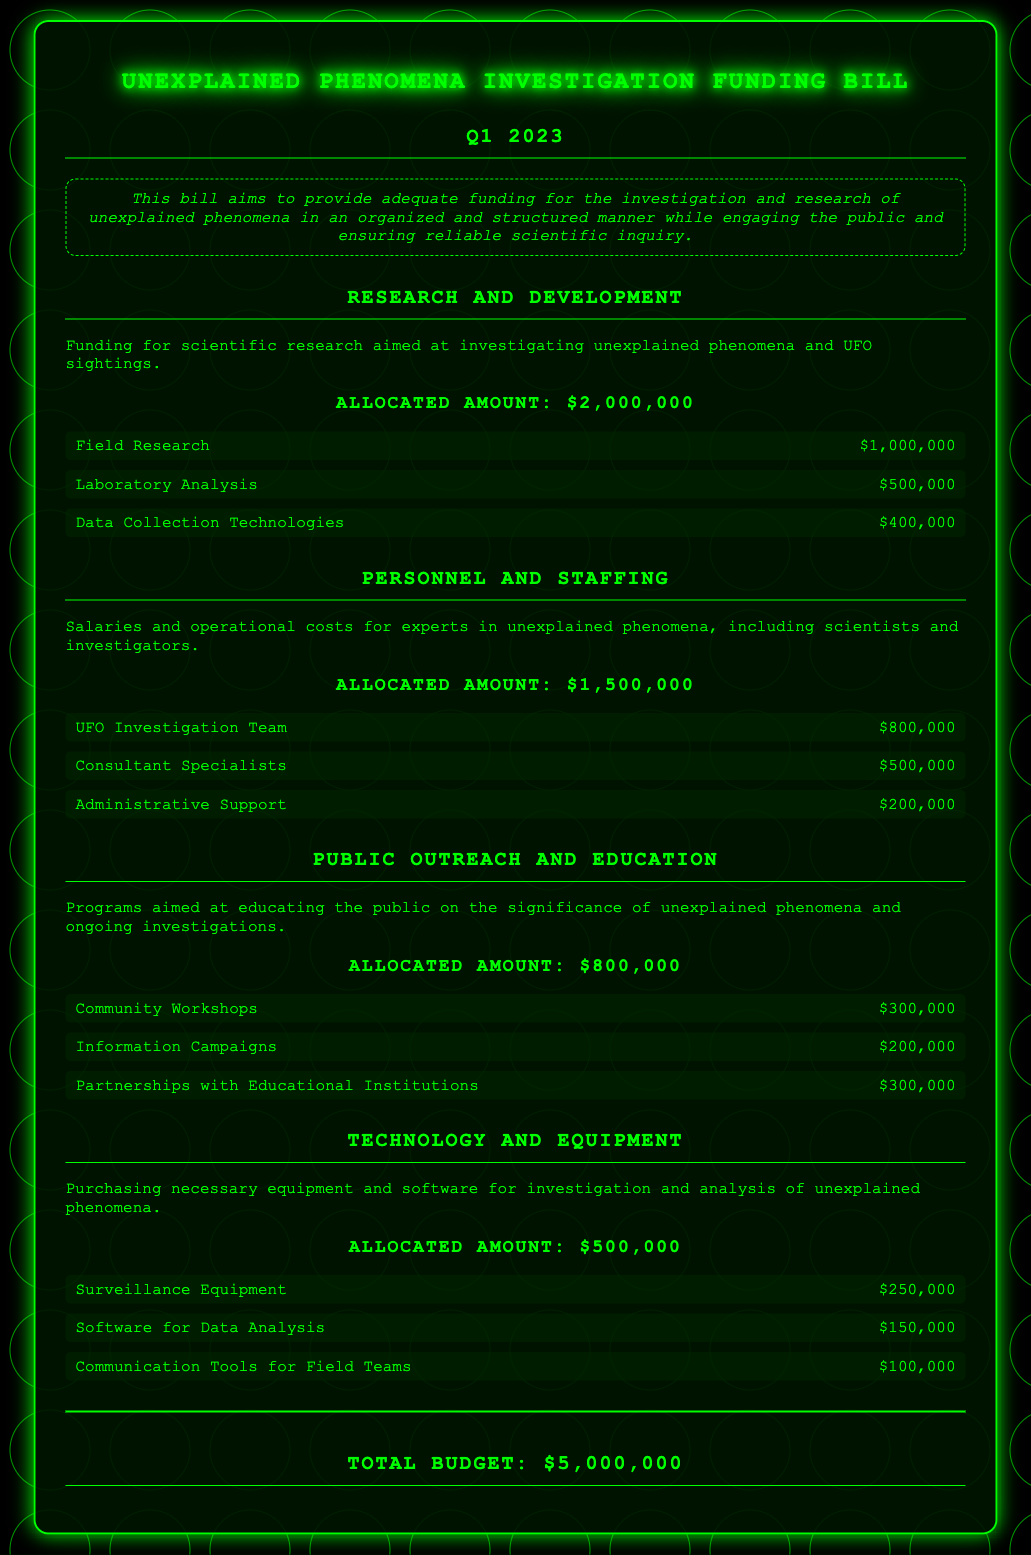what is the total allocated budget? The total allocated budget is the sum of all allocated amounts for each category in the document, which equals $2,000,000 + $1,500,000 + $800,000 + $500,000 = $5,000,000.
Answer: $5,000,000 how much is allocated for Personnel and Staffing? The allocated amount for Personnel and Staffing is explicitly stated in the document.
Answer: $1,500,000 what is the allocated amount for Community Workshops? The amount allocated for Community Workshops is detailed under Public Outreach and Education section.
Answer: $300,000 who receives the highest allocation under Technology and Equipment? The highest allocation under Technology and Equipment refers to the subcategory with the largest amount, which is Surveillance Equipment.
Answer: Surveillance Equipment what is the primary purpose of the bill? The primary aim of the bill is mentioned in the summary at the beginning of the document.
Answer: Funding for the investigation and research of unexplained phenomena how many subcategories are listed under Research and Development? The number of subcategories listed under Research and Development is determined by counting the individual entries provided in that category.
Answer: 3 which category has the least allocated amount? The category with the least allocated amount is identified from the list of allocations provided in the document.
Answer: Technology and Equipment how much is allocated for Information Campaigns? The amount for Information Campaigns is specified under Public Outreach and Education and can be found by looking at the individual subcategory amounts.
Answer: $200,000 what is the main focus of the bill's Public Outreach and Education section? The main focus is extracted from the expressed intent of the Public Outreach and Education category in the document.
Answer: Educating the public on the significance of unexplained phenomena 